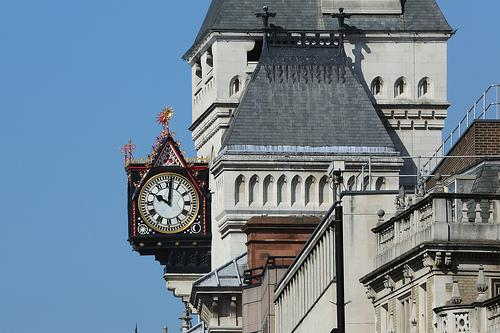What is the main item of focus in the image and its notable features? The primary item is a clock with a pointed top, gold ring, black arms, and Roman numerals on a building. Summarize the major subject in the image and its distinguishing attributes. A large outside clock with black Roman numerals, black arms, and a gold ring is prominently displayed on a building. State the primary element in the image and outline its remarkable features. The main element is a clock on a building, showcasing black Roman numerals, black hands, and a gold ring surrounding it. Provide a brief description of the primary object in the image. A black, white, and gold clock with Roman numerals is attached to a building. Write about the principal object in the image and its notable aspects. The principal object is a clock with a pointed top, a gold ring, black numbers, and black arms extending from a building. Highlight the chief subject in the image and its striking characteristics. The chief subject is an outdoor clock with a triangular top, gold accents, black Roman numerals, and black hands on a building. Explain the central object in the image and its unique traits. The central object is a large outdoor clock with a pointed top, gold trim, black Roman numerals, and black arms on a building. Specify the key subject in the image and its signature attributes. The key subject is a clock at the top of a building with black numbers and arms, a gold ring, and a pointed top. Identify the prominent item in the image and describe its key features. The main item is a clock at the top of a building, featuring black numbers, black arms, and a gold ring around it. Mention the main subject in the image along with its distinct characteristics. An outdoor clock with a triangular top, gold accents, black numbers, and black hands is attached to a building. 